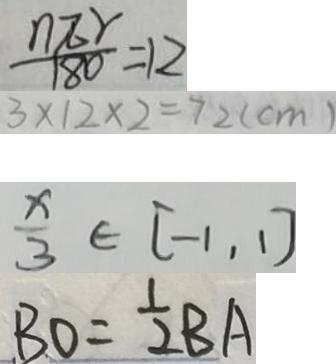<formula> <loc_0><loc_0><loc_500><loc_500>\frac { n \pi r } { 1 8 0 } = 1 2 
 3 \times 1 2 \times 2 = 7 2 ( c m ) 
 \frac { x } { 3 } \in [ - 1 , 1 ] 
 B O = \frac { 1 } { 2 } B A</formula> 